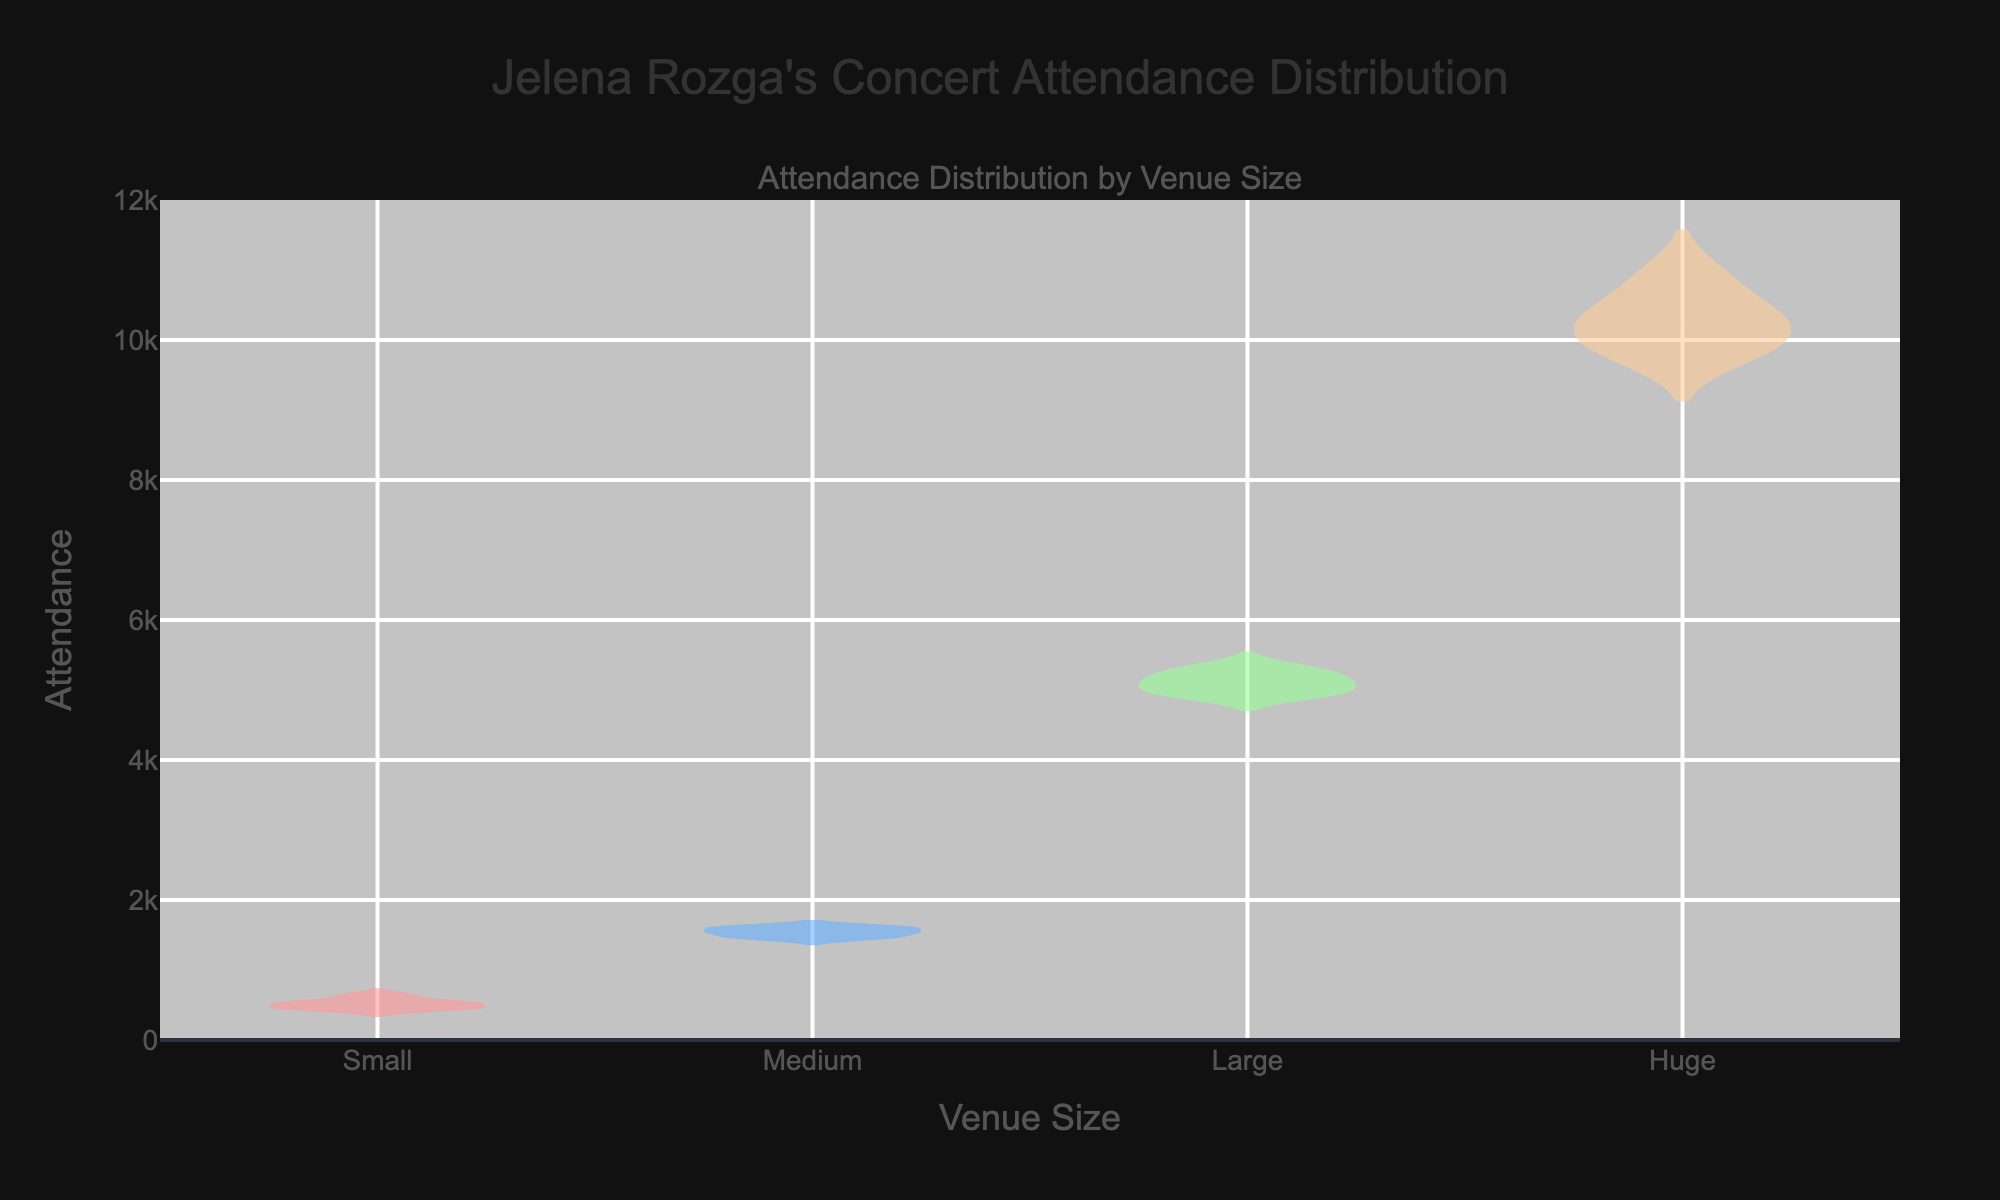What is the title of the figure? The title of the figure is displayed at the top and reads "Jelena Rozga's Concert Attendance Distribution".
Answer: Jelena Rozga's Concert Attendance Distribution What does the y-axis represent? The y-axis represents the attendance at Jelena Rozga's concerts, showing the number of people attending.
Answer: Attendance Which venue size category has the highest median attendance? The median attendance is the middle value when the data is arranged in order. In the figure, the "Huge" venue category has the highest median attendance, visually represented by the location of the center line in the violin plot.
Answer: Huge How does the mean attendance at Small venues compare to that at Medium venues? Mean attendance is represented by the mean line in each violin plot. Observing the figure, the mean attendance at Medium venues is higher than that at Small venues.
Answer: Medium is higher Which venue size shows the greatest range of attendance values? The range of attendance values is the difference between the highest and lowest values. The "Huge" venue size shows the greatest range as indicated by the spread of the violin plot.
Answer: Huge What color represents the attendance data for Large venues? The color representing the attendance data for Large venues can be determined by looking at the corresponding violin plot. It is light blue.
Answer: Light blue What is the approximate maximum attendance recorded for Huge venues? The maximum attendance is the highest value on the y-axis within the violin plot for Huge venues. The plot shows the maximum just a bit above 10,900.
Answer: 10,900 What is the average attendance for Small venues? Average attendance is found by summing the data points and dividing by the number of data points: (500 + 450 + 620 + 480 + 530) / 5 = 2580 / 5 = 516.
Answer: 516 Compare the spread of attendance values between Large and Medium venues. The spread of attendance values, indicated by the width and length of the violin plots, is wider and longer for Large venues compared to Medium venues, indicating a higher variance in attendance.
Answer: Larger spread for Large venues Which venue size category has the least variability in attendance? Variability can be observed by the width of the violin plot (narrower plots indicate less variability). The "Medium" venue size, having a relatively narrow spread, indicates the least variability in attendance.
Answer: Medium 